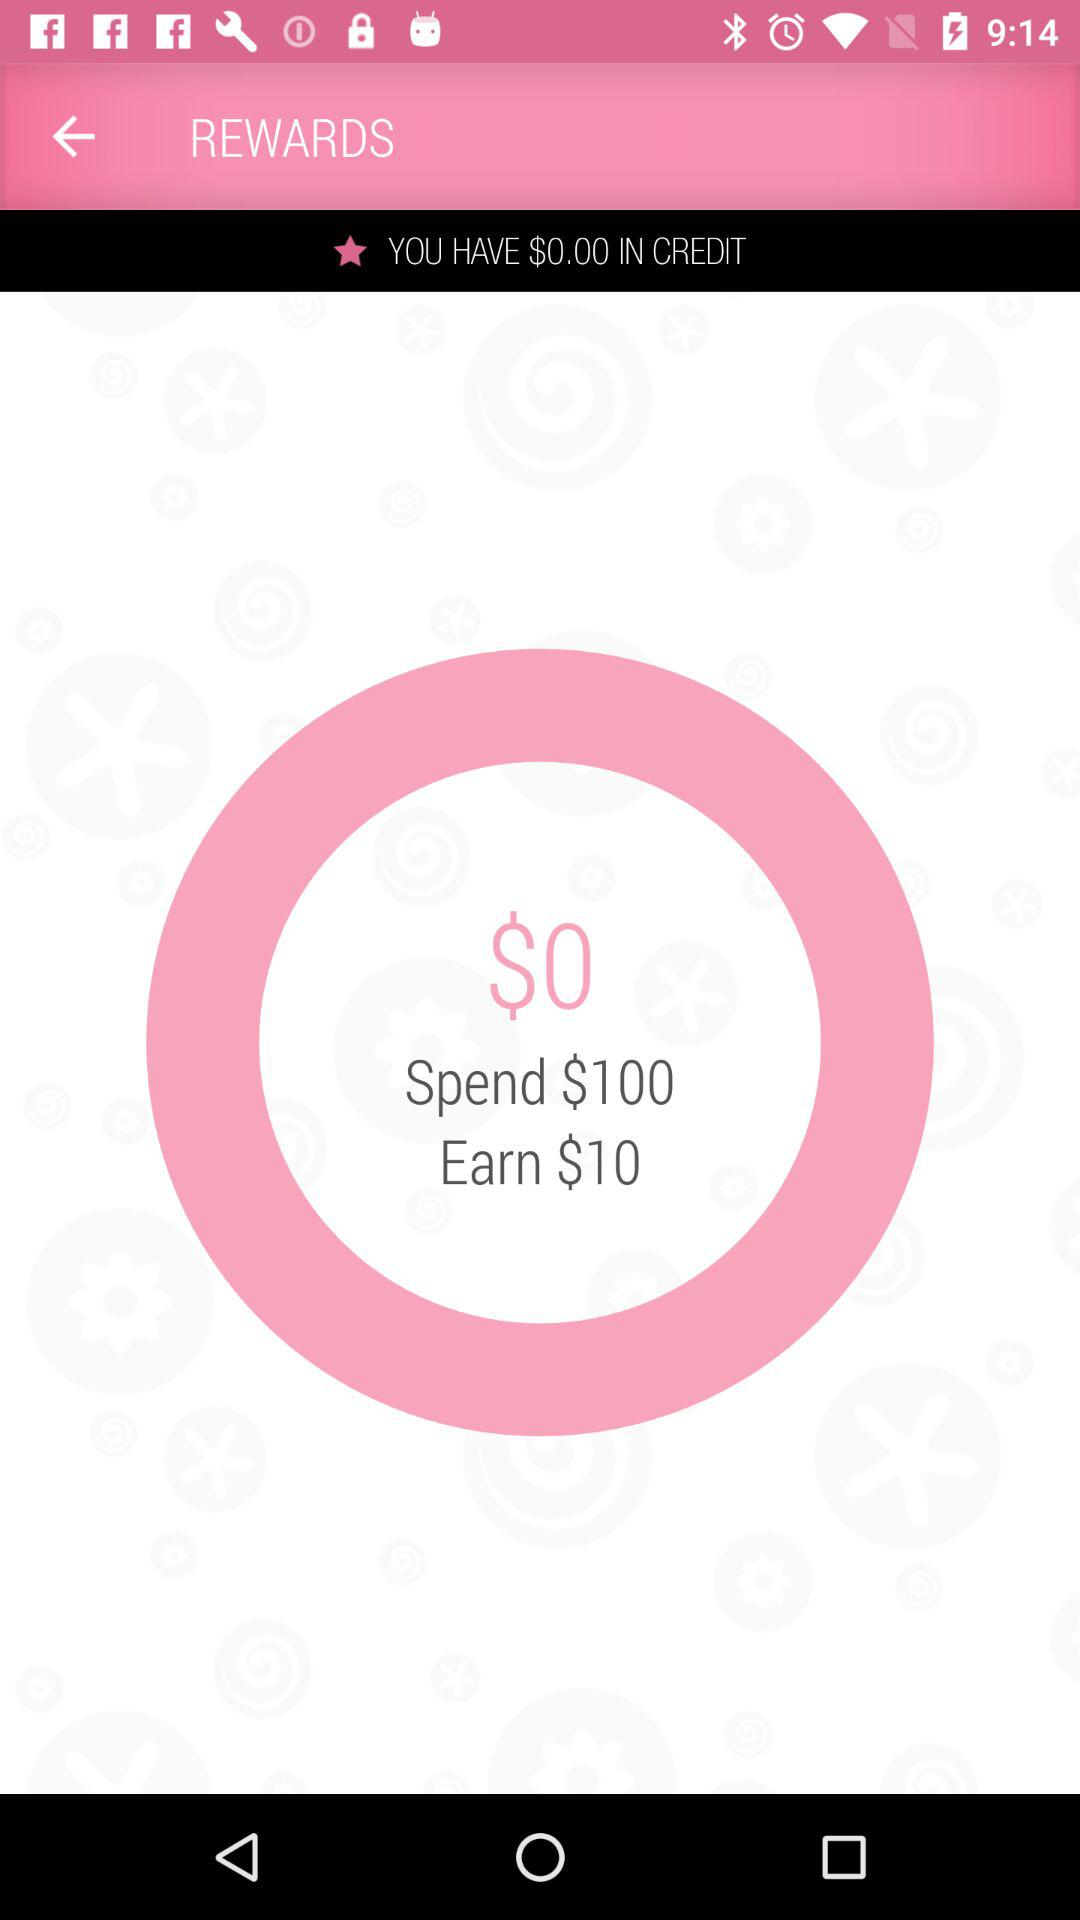What is the amount that can be earned? The amount that can be earned is $10. 